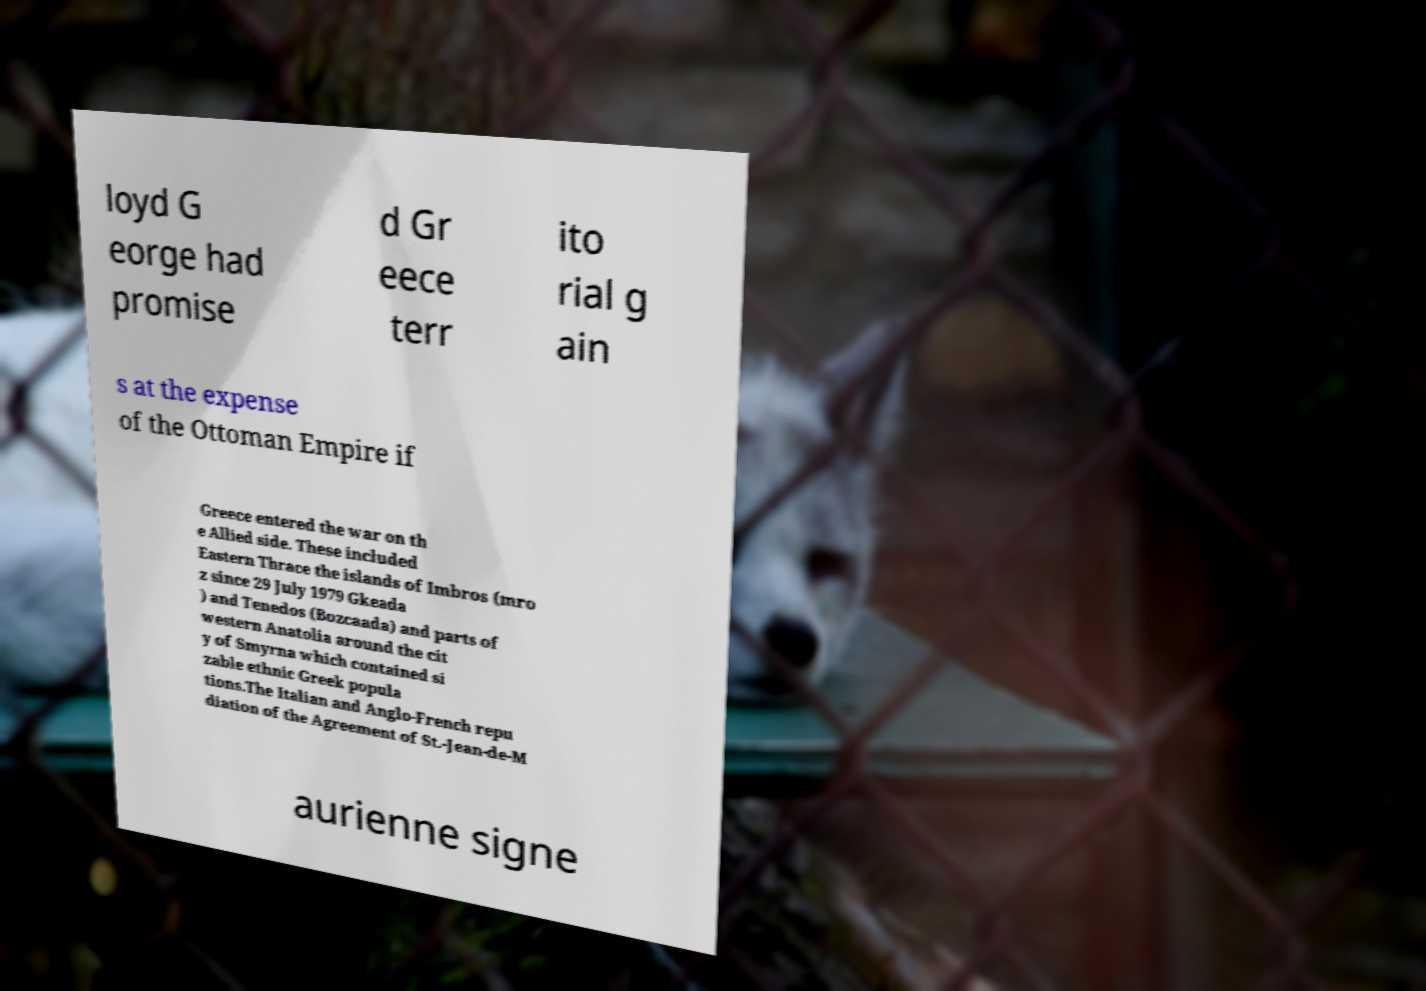Please read and relay the text visible in this image. What does it say? loyd G eorge had promise d Gr eece terr ito rial g ain s at the expense of the Ottoman Empire if Greece entered the war on th e Allied side. These included Eastern Thrace the islands of Imbros (mro z since 29 July 1979 Gkeada ) and Tenedos (Bozcaada) and parts of western Anatolia around the cit y of Smyrna which contained si zable ethnic Greek popula tions.The Italian and Anglo-French repu diation of the Agreement of St.-Jean-de-M aurienne signe 